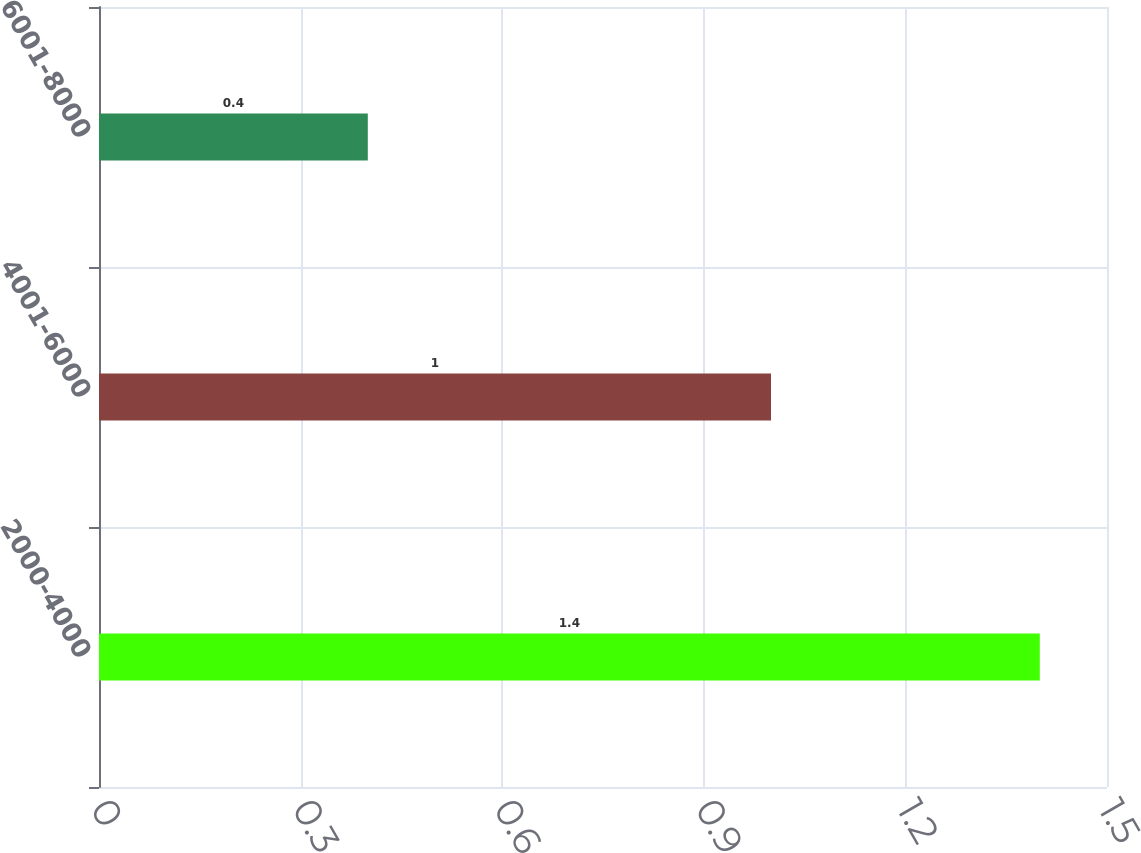Convert chart. <chart><loc_0><loc_0><loc_500><loc_500><bar_chart><fcel>2000-4000<fcel>4001-6000<fcel>6001-8000<nl><fcel>1.4<fcel>1<fcel>0.4<nl></chart> 